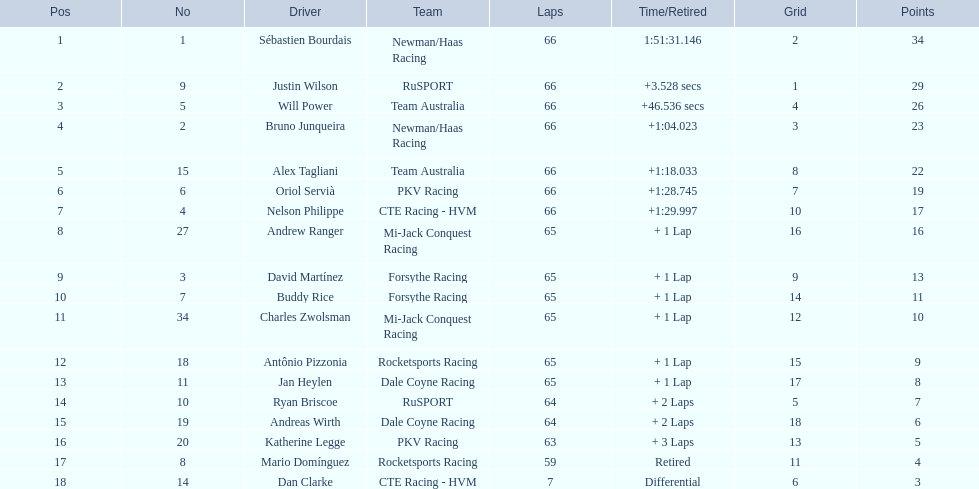Which teams took part in the 2006 gran premio telmex? Newman/Haas Racing, RuSPORT, Team Australia, Newman/Haas Racing, Team Australia, PKV Racing, CTE Racing - HVM, Mi-Jack Conquest Racing, Forsythe Racing, Forsythe Racing, Mi-Jack Conquest Racing, Rocketsports Racing, Dale Coyne Racing, RuSPORT, Dale Coyne Racing, PKV Racing, Rocketsports Racing, CTE Racing - HVM. Who were the team members? Sébastien Bourdais, Justin Wilson, Will Power, Bruno Junqueira, Alex Tagliani, Oriol Servià, Nelson Philippe, Andrew Ranger, David Martínez, Buddy Rice, Charles Zwolsman, Antônio Pizzonia, Jan Heylen, Ryan Briscoe, Andreas Wirth, Katherine Legge, Mario Domínguez, Dan Clarke. Which driver ended up in the last position? Dan Clarke. 